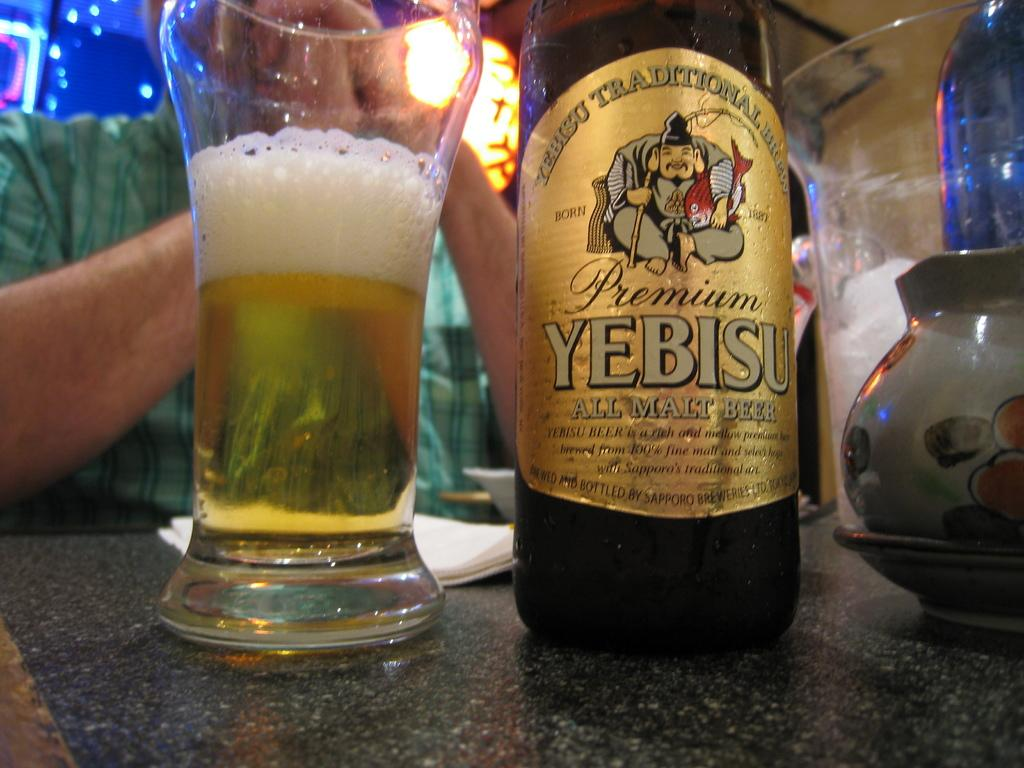What is in the glass that is visible in the image? There is a drink in the glass in the image. What other objects can be seen on the table in the image? There is a bottle, a plate, and a cup on the table in the image. What might be used for cleaning or wiping in the image? There is a tissue paper in the image for cleaning or wiping. Who is present near the table in the image? There is a person sitting near the table in the image. What is the acoustics like in the image? The image does not provide information about the acoustics, as it focuses on objects on a table and a person sitting near it. 